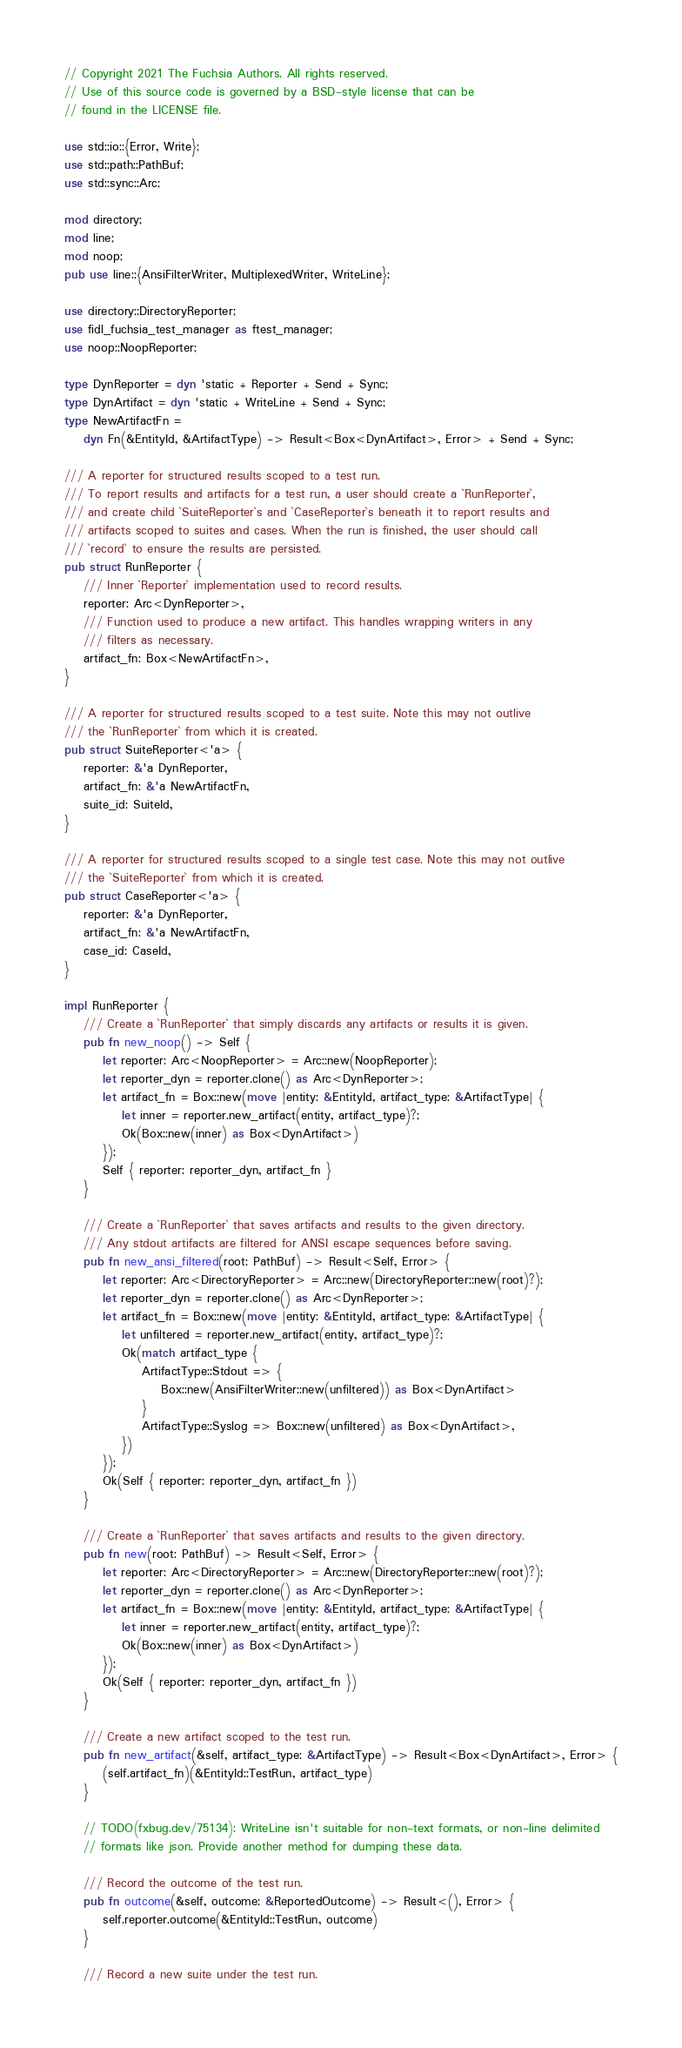<code> <loc_0><loc_0><loc_500><loc_500><_Rust_>// Copyright 2021 The Fuchsia Authors. All rights reserved.
// Use of this source code is governed by a BSD-style license that can be
// found in the LICENSE file.

use std::io::{Error, Write};
use std::path::PathBuf;
use std::sync::Arc;

mod directory;
mod line;
mod noop;
pub use line::{AnsiFilterWriter, MultiplexedWriter, WriteLine};

use directory::DirectoryReporter;
use fidl_fuchsia_test_manager as ftest_manager;
use noop::NoopReporter;

type DynReporter = dyn 'static + Reporter + Send + Sync;
type DynArtifact = dyn 'static + WriteLine + Send + Sync;
type NewArtifactFn =
    dyn Fn(&EntityId, &ArtifactType) -> Result<Box<DynArtifact>, Error> + Send + Sync;

/// A reporter for structured results scoped to a test run.
/// To report results and artifacts for a test run, a user should create a `RunReporter`,
/// and create child `SuiteReporter`s and `CaseReporter`s beneath it to report results and
/// artifacts scoped to suites and cases. When the run is finished, the user should call
/// `record` to ensure the results are persisted.
pub struct RunReporter {
    /// Inner `Reporter` implementation used to record results.
    reporter: Arc<DynReporter>,
    /// Function used to produce a new artifact. This handles wrapping writers in any
    /// filters as necessary.
    artifact_fn: Box<NewArtifactFn>,
}

/// A reporter for structured results scoped to a test suite. Note this may not outlive
/// the `RunReporter` from which it is created.
pub struct SuiteReporter<'a> {
    reporter: &'a DynReporter,
    artifact_fn: &'a NewArtifactFn,
    suite_id: SuiteId,
}

/// A reporter for structured results scoped to a single test case. Note this may not outlive
/// the `SuiteReporter` from which it is created.
pub struct CaseReporter<'a> {
    reporter: &'a DynReporter,
    artifact_fn: &'a NewArtifactFn,
    case_id: CaseId,
}

impl RunReporter {
    /// Create a `RunReporter` that simply discards any artifacts or results it is given.
    pub fn new_noop() -> Self {
        let reporter: Arc<NoopReporter> = Arc::new(NoopReporter);
        let reporter_dyn = reporter.clone() as Arc<DynReporter>;
        let artifact_fn = Box::new(move |entity: &EntityId, artifact_type: &ArtifactType| {
            let inner = reporter.new_artifact(entity, artifact_type)?;
            Ok(Box::new(inner) as Box<DynArtifact>)
        });
        Self { reporter: reporter_dyn, artifact_fn }
    }

    /// Create a `RunReporter` that saves artifacts and results to the given directory.
    /// Any stdout artifacts are filtered for ANSI escape sequences before saving.
    pub fn new_ansi_filtered(root: PathBuf) -> Result<Self, Error> {
        let reporter: Arc<DirectoryReporter> = Arc::new(DirectoryReporter::new(root)?);
        let reporter_dyn = reporter.clone() as Arc<DynReporter>;
        let artifact_fn = Box::new(move |entity: &EntityId, artifact_type: &ArtifactType| {
            let unfiltered = reporter.new_artifact(entity, artifact_type)?;
            Ok(match artifact_type {
                ArtifactType::Stdout => {
                    Box::new(AnsiFilterWriter::new(unfiltered)) as Box<DynArtifact>
                }
                ArtifactType::Syslog => Box::new(unfiltered) as Box<DynArtifact>,
            })
        });
        Ok(Self { reporter: reporter_dyn, artifact_fn })
    }

    /// Create a `RunReporter` that saves artifacts and results to the given directory.
    pub fn new(root: PathBuf) -> Result<Self, Error> {
        let reporter: Arc<DirectoryReporter> = Arc::new(DirectoryReporter::new(root)?);
        let reporter_dyn = reporter.clone() as Arc<DynReporter>;
        let artifact_fn = Box::new(move |entity: &EntityId, artifact_type: &ArtifactType| {
            let inner = reporter.new_artifact(entity, artifact_type)?;
            Ok(Box::new(inner) as Box<DynArtifact>)
        });
        Ok(Self { reporter: reporter_dyn, artifact_fn })
    }

    /// Create a new artifact scoped to the test run.
    pub fn new_artifact(&self, artifact_type: &ArtifactType) -> Result<Box<DynArtifact>, Error> {
        (self.artifact_fn)(&EntityId::TestRun, artifact_type)
    }

    // TODO(fxbug.dev/75134): WriteLine isn't suitable for non-text formats, or non-line delimited
    // formats like json. Provide another method for dumping these data.

    /// Record the outcome of the test run.
    pub fn outcome(&self, outcome: &ReportedOutcome) -> Result<(), Error> {
        self.reporter.outcome(&EntityId::TestRun, outcome)
    }

    /// Record a new suite under the test run.</code> 